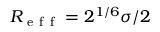Convert formula to latex. <formula><loc_0><loc_0><loc_500><loc_500>R _ { e f f } = 2 ^ { 1 / 6 } \sigma / 2</formula> 